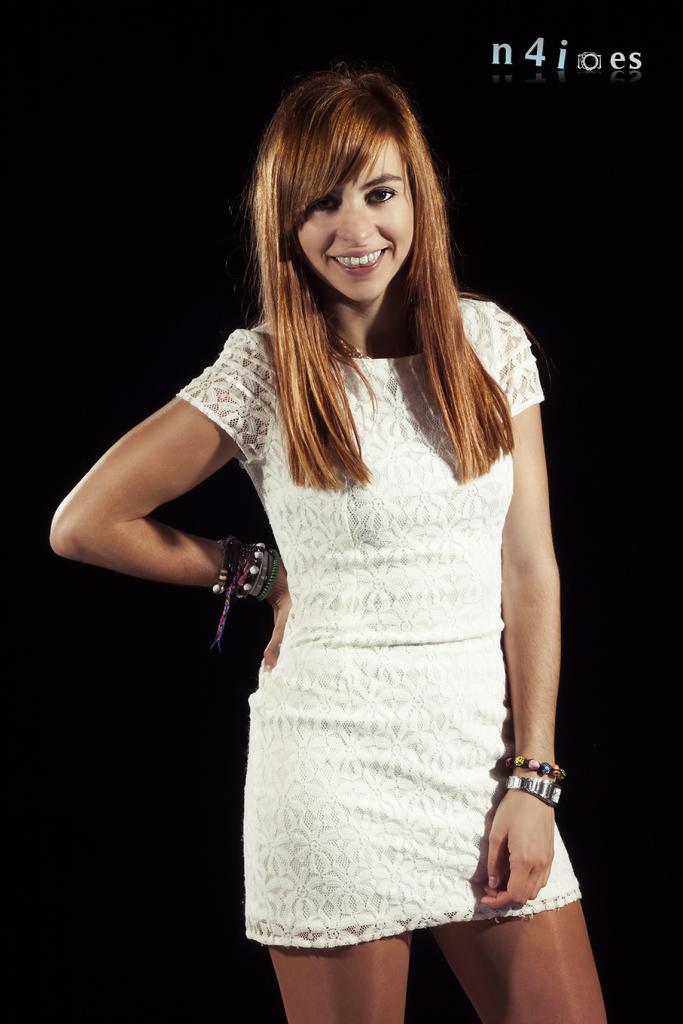In one or two sentences, can you explain what this image depicts? In this image we can see a woman wearing white dress is stunning. 